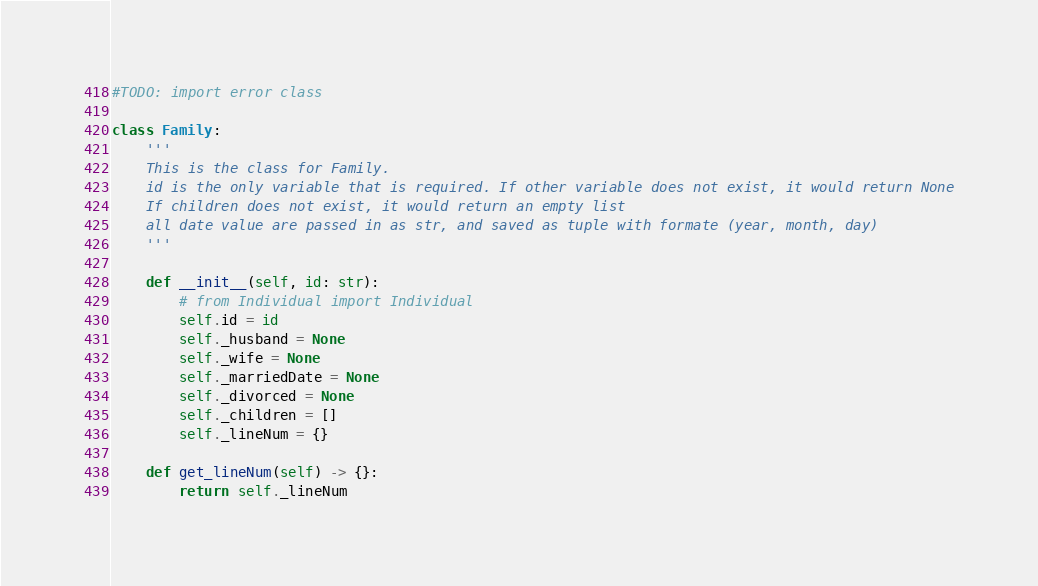<code> <loc_0><loc_0><loc_500><loc_500><_Python_>#TODO: import error class

class Family:
    '''
    This is the class for Family.
    id is the only variable that is required. If other variable does not exist, it would return None
    If children does not exist, it would return an empty list
    all date value are passed in as str, and saved as tuple with formate (year, month, day)
    '''

    def __init__(self, id: str):
        # from Individual import Individual
        self.id = id
        self._husband = None
        self._wife = None
        self._marriedDate = None
        self._divorced = None
        self._children = []
        self._lineNum = {}

    def get_lineNum(self) -> {}:
        return self._lineNum
</code> 